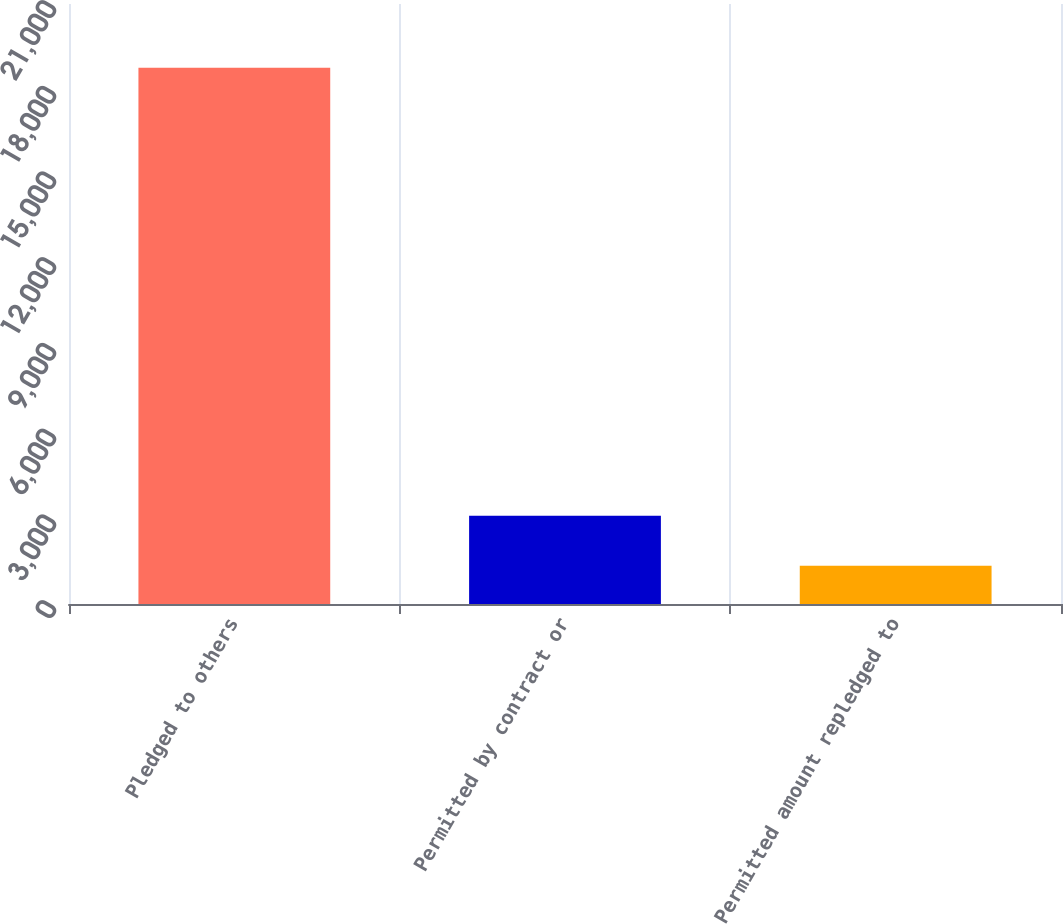Convert chart to OTSL. <chart><loc_0><loc_0><loc_500><loc_500><bar_chart><fcel>Pledged to others<fcel>Permitted by contract or<fcel>Permitted amount repledged to<nl><fcel>18772<fcel>3085.9<fcel>1343<nl></chart> 